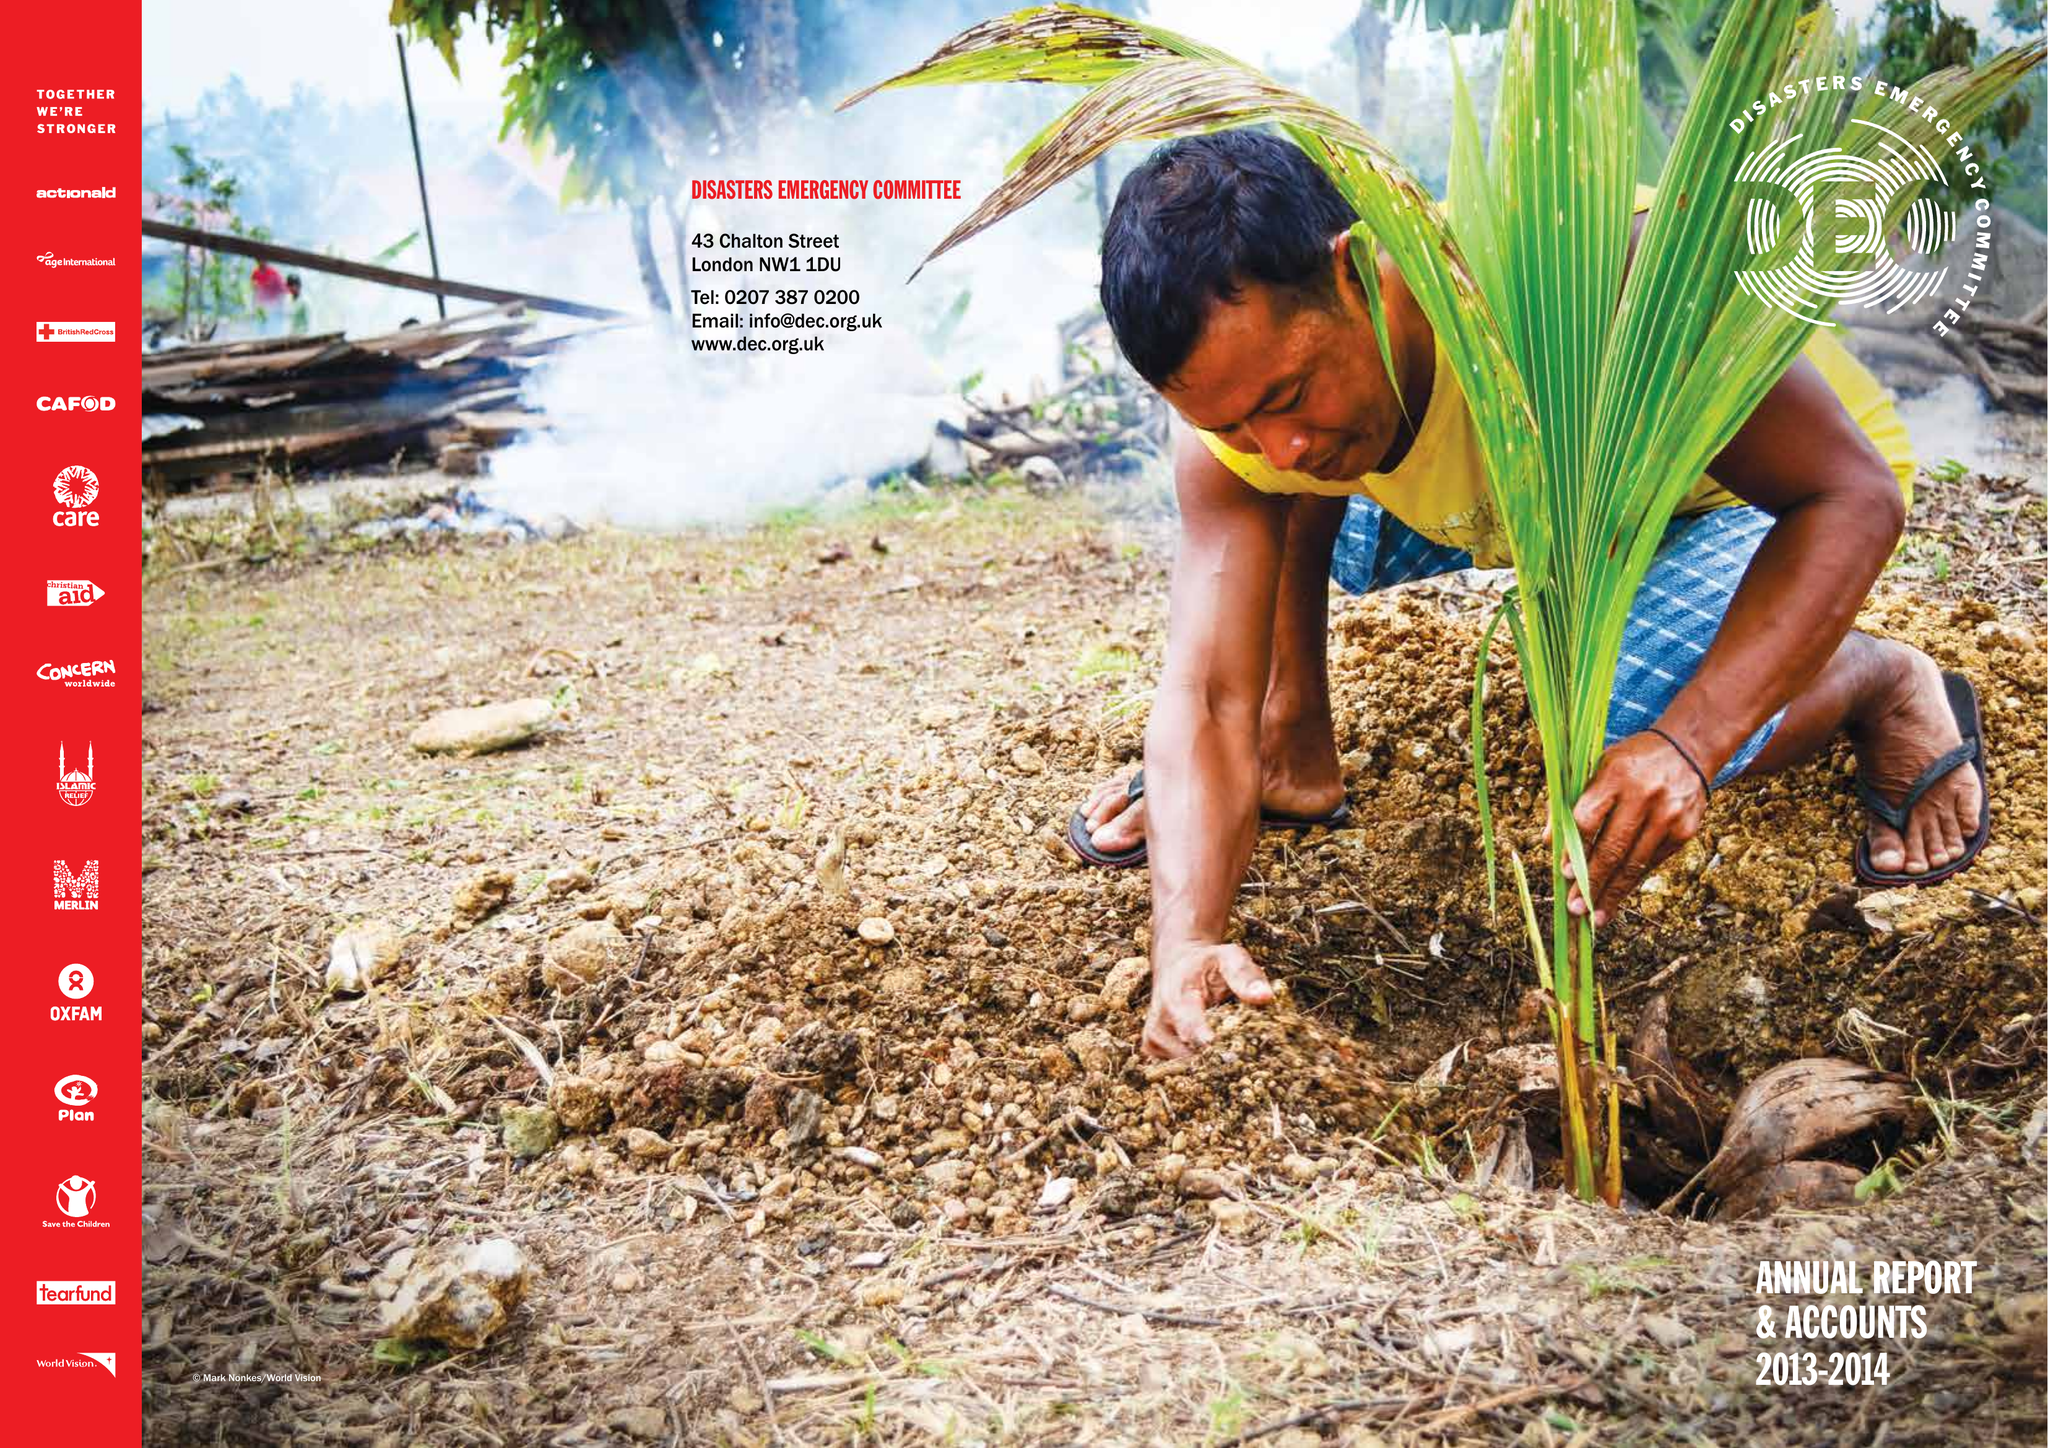What is the value for the address__postcode?
Answer the question using a single word or phrase. WC1H 9NA 